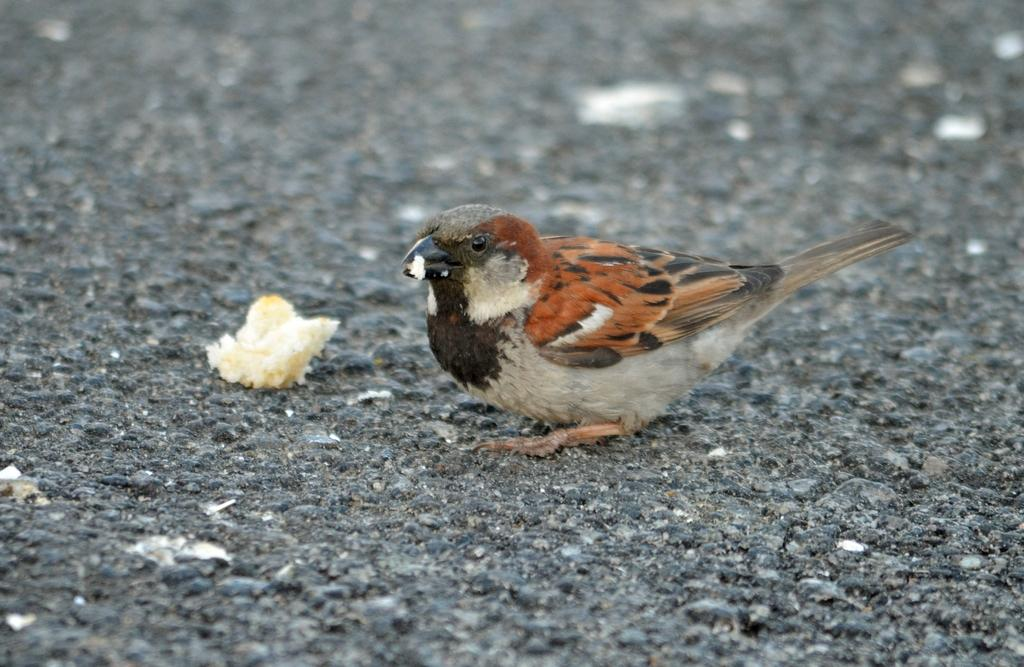What is the main feature of the image? There is a road in the image. What can be seen on the road? There is a sparrow on the road, and there is food on the road as well. Can you describe the quality of the image? The top of the image is blurred. What type of cub is sitting on the chair in the image? There is no cub or chair present in the image. 